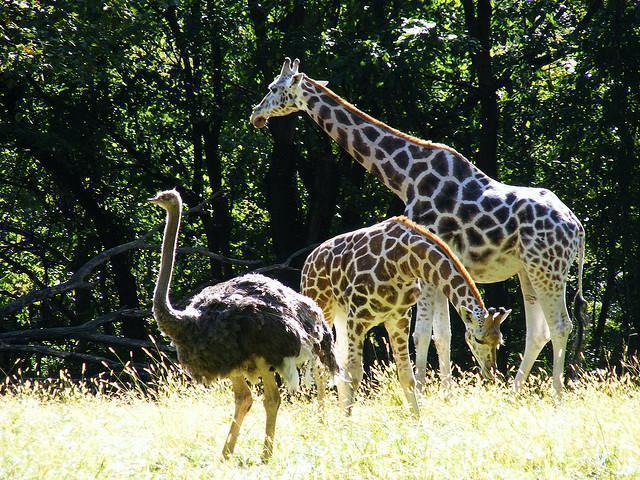How many giraffes are standing around the forest near the ostrich?
Pick the right solution, then justify: 'Answer: answer
Rationale: rationale.'
Options: Three, four, two, five. Answer: two.
Rationale: There are two yellow animals with very long necks on all fours. 